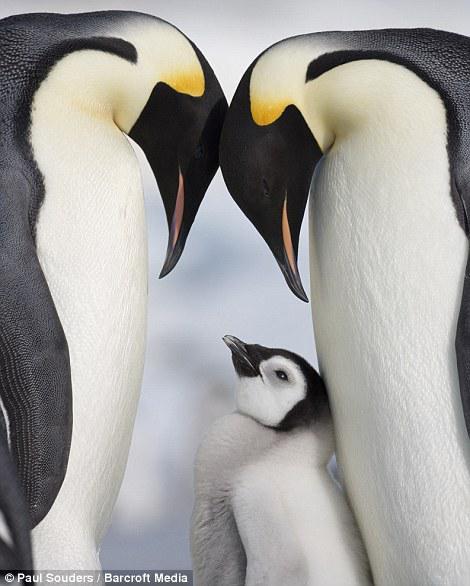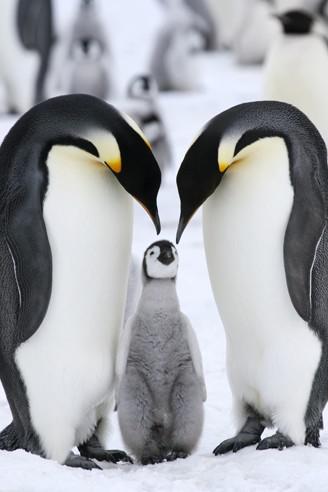The first image is the image on the left, the second image is the image on the right. Examine the images to the left and right. Is the description "One image includes a penguin with brown fuzzy feathers, and the other includes a gray fuzzy baby penguin." accurate? Answer yes or no. No. The first image is the image on the left, the second image is the image on the right. For the images shown, is this caption "In one of the photos, one of the penguins is brown, and in the other, none of the penguins are brown." true? Answer yes or no. No. 